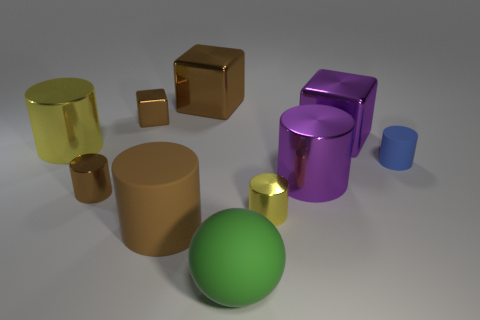Subtract all purple cylinders. How many cylinders are left? 5 Subtract all tiny yellow metallic cylinders. How many cylinders are left? 5 Subtract all red cylinders. Subtract all yellow blocks. How many cylinders are left? 6 Subtract all cylinders. How many objects are left? 4 Add 5 brown metallic cubes. How many brown metallic cubes exist? 7 Subtract 0 gray cylinders. How many objects are left? 10 Subtract all gray cubes. Subtract all tiny brown metal things. How many objects are left? 8 Add 2 tiny yellow cylinders. How many tiny yellow cylinders are left? 3 